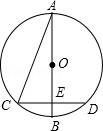How does the knowledge of angle CAB being 22.5 degrees help in solving other parts of the circle's properties? Knowing angle CAB is 22.5 degrees is crucial for deducing that the angle opposite to it in triangle COE, which is angle CEO, sums up to twice the angle CAB, resulting in 45 degrees. This establishes triangle COE as an isosceles right triangle, a configuration that significantly simplifies calculating lengths within the triangle, particularly the radius of the circle. 